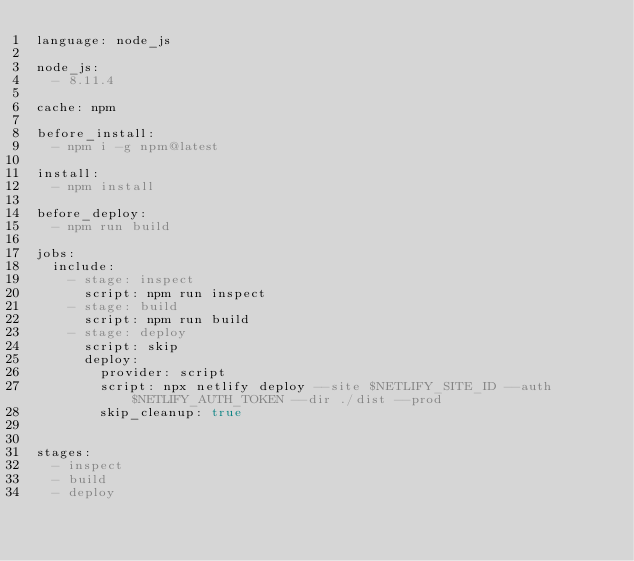<code> <loc_0><loc_0><loc_500><loc_500><_YAML_>language: node_js

node_js:
  - 8.11.4

cache: npm

before_install:
  - npm i -g npm@latest

install:
  - npm install

before_deploy:
  - npm run build

jobs:
  include:
    - stage: inspect
      script: npm run inspect
    - stage: build
      script: npm run build
    - stage: deploy
      script: skip
      deploy:
        provider: script
        script: npx netlify deploy --site $NETLIFY_SITE_ID --auth $NETLIFY_AUTH_TOKEN --dir ./dist --prod
        skip_cleanup: true


stages:
  - inspect
  - build
  - deploy
</code> 